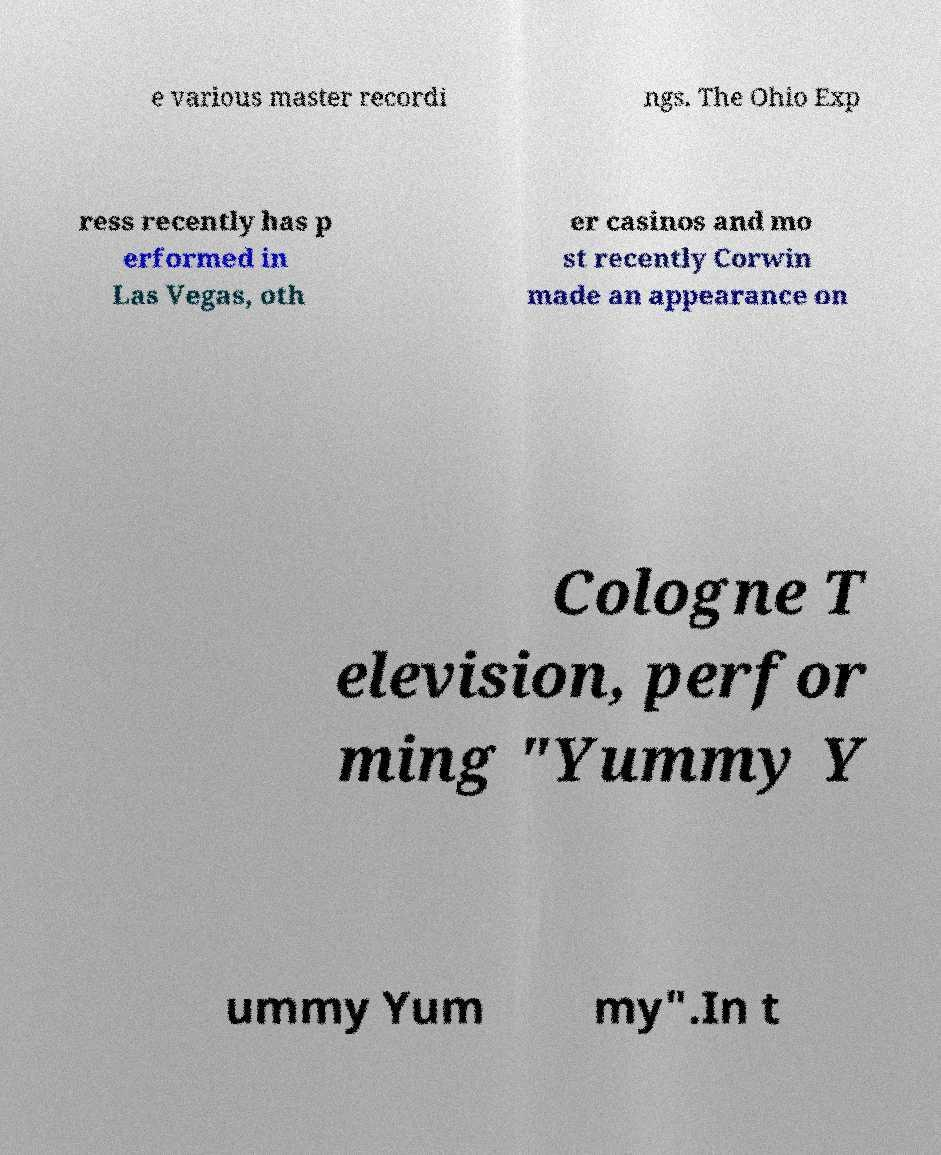For documentation purposes, I need the text within this image transcribed. Could you provide that? e various master recordi ngs. The Ohio Exp ress recently has p erformed in Las Vegas, oth er casinos and mo st recently Corwin made an appearance on Cologne T elevision, perfor ming "Yummy Y ummy Yum my".In t 